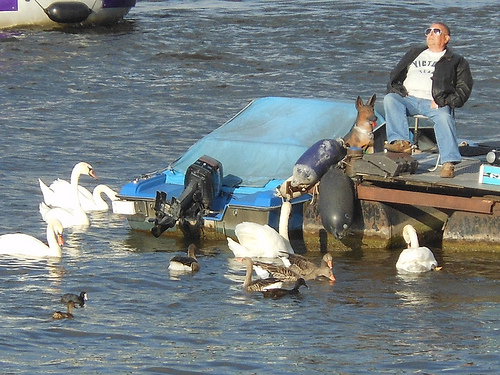<image>
Is the dog on the boat? No. The dog is not positioned on the boat. They may be near each other, but the dog is not supported by or resting on top of the boat. 